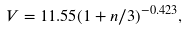Convert formula to latex. <formula><loc_0><loc_0><loc_500><loc_500>V = 1 1 . 5 5 ( 1 + n / 3 ) ^ { - 0 . 4 2 3 } ,</formula> 